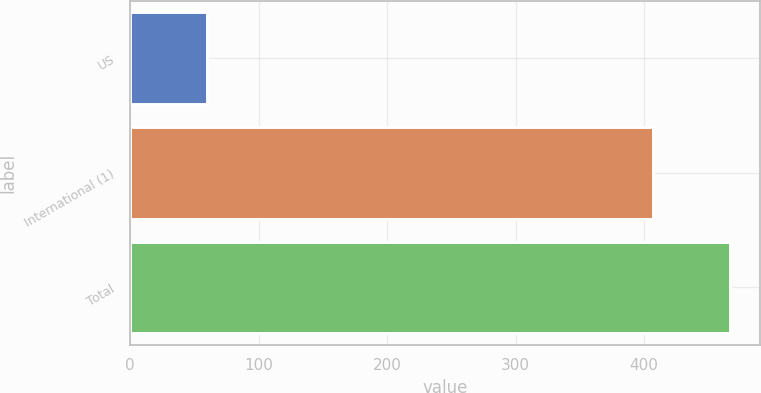Convert chart to OTSL. <chart><loc_0><loc_0><loc_500><loc_500><bar_chart><fcel>US<fcel>International (1)<fcel>Total<nl><fcel>60<fcel>407<fcel>467<nl></chart> 